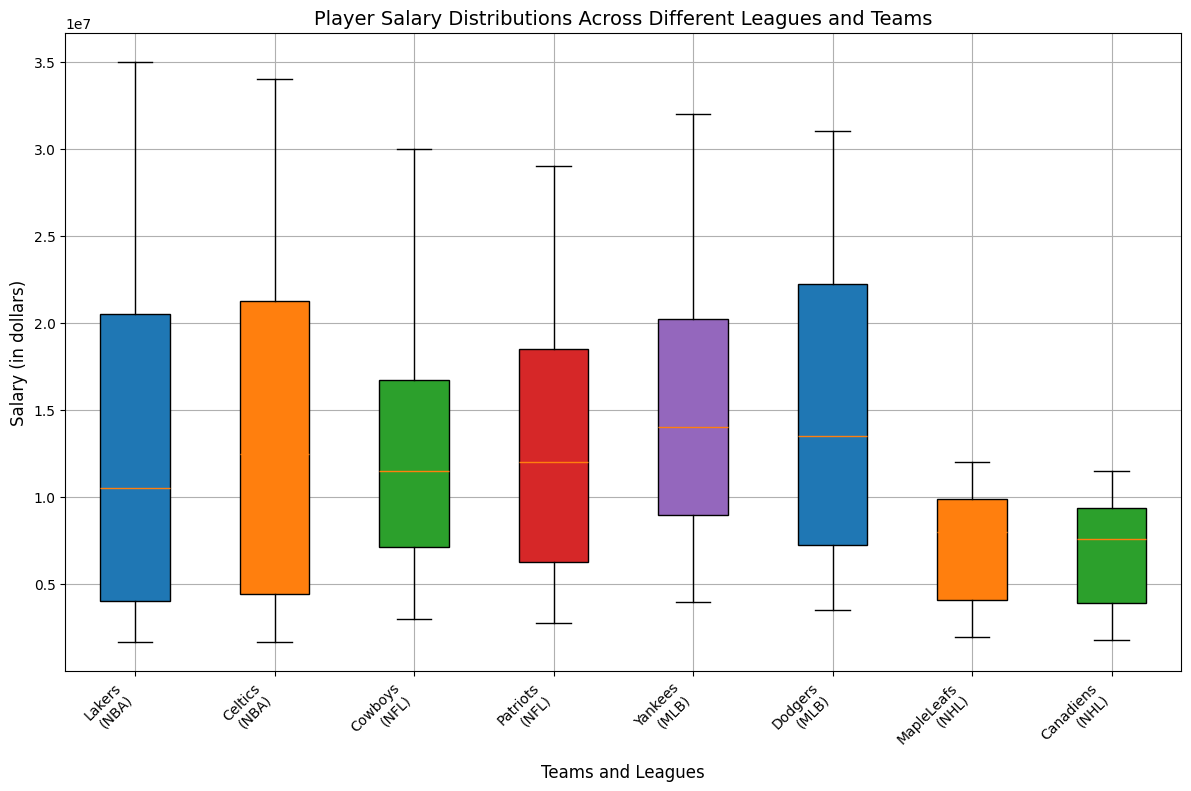Which team across all leagues has the highest player salary? To determine the team with the highest player salary, look for the boxplot with the highest maximum value on the salary axis. The maximum salary is found in the NBA Lakers, which has a player earning $35,000,000.
Answer: NBA Lakers Which league has the most spread in player salaries? To identify the league with the most spread in player salaries, compare the range (distance between the minimum and maximum values) of all boxplots. The NBA has the widest ranges, as larger differences between the top and bottom of the boxes and their whiskers are observed in NBA teams.
Answer: NBA What is the median salary of the Dodgers? Look for the line inside the Dodgers boxplot that represents the median. The median salary of the Dodgers is $12,000,000.
Answer: $12,000,000 How does the salary distribution of the Patriots compare to the Cowboys? Compare the boxplots of the Patriots and Cowboys. Both have a similar interquartile range, but the Patriots' middle 50% of salaries (the box) is slightly higher than that of the Cowboys. Additionally, the medians are similar, but the Cowboys have a slightly higher maximum salary than the Patriots.
Answer: Patriots have a slightly higher median, similar interquartile range Which team in the NHL has a higher salary range, MapleLeafs or Canadiens? Compare the distance between the minimum and maximum salaries (whiskers and/or outliers) in both the Maple Leafs and Canadiens boxplots. The Maple Leafs have a slightly wider range with a higher maximum and lower minimum salary.
Answer: Maple Leafs Which league has generally the highest player salaries? Look at the position of the majority of the boxes and the height of their medians across the different leagues. The NBA boxplots appear highest on the salary axis, indicating generally higher player salaries.
Answer: NBA What is the average salary of the top 3 players in the Yankees? The top 3 salaries for the Yankees are $32,000,000, $27,000,000, and $18,000,000. The sum is $32,000,000 + $27,000,000 + $18,000,000 = $77,000,000, and the average is $77,000,000 / 3 = $25,666,667.
Answer: $25,666,667 How does the salary range of the MapleLeafs compare to that of the Yankees? Compare the salary ranges by looking at the distance between the minimum and maximum salaries in their respective boxplots. The Yankees have a much wider salary range with a higher maximum salary compared to the Maple Leafs.
Answer: Yankees have a wider range What is the median salary of the lowest-paid quarter of players in the Celtics? The lowest-paid quarter of players corresponds to the lower whisker to the bottom of the box. The median of this range can be approximated by looking halfway down this range. For the Celtics, this median appears close to about $2,500,000.
Answer: $2,500,000 